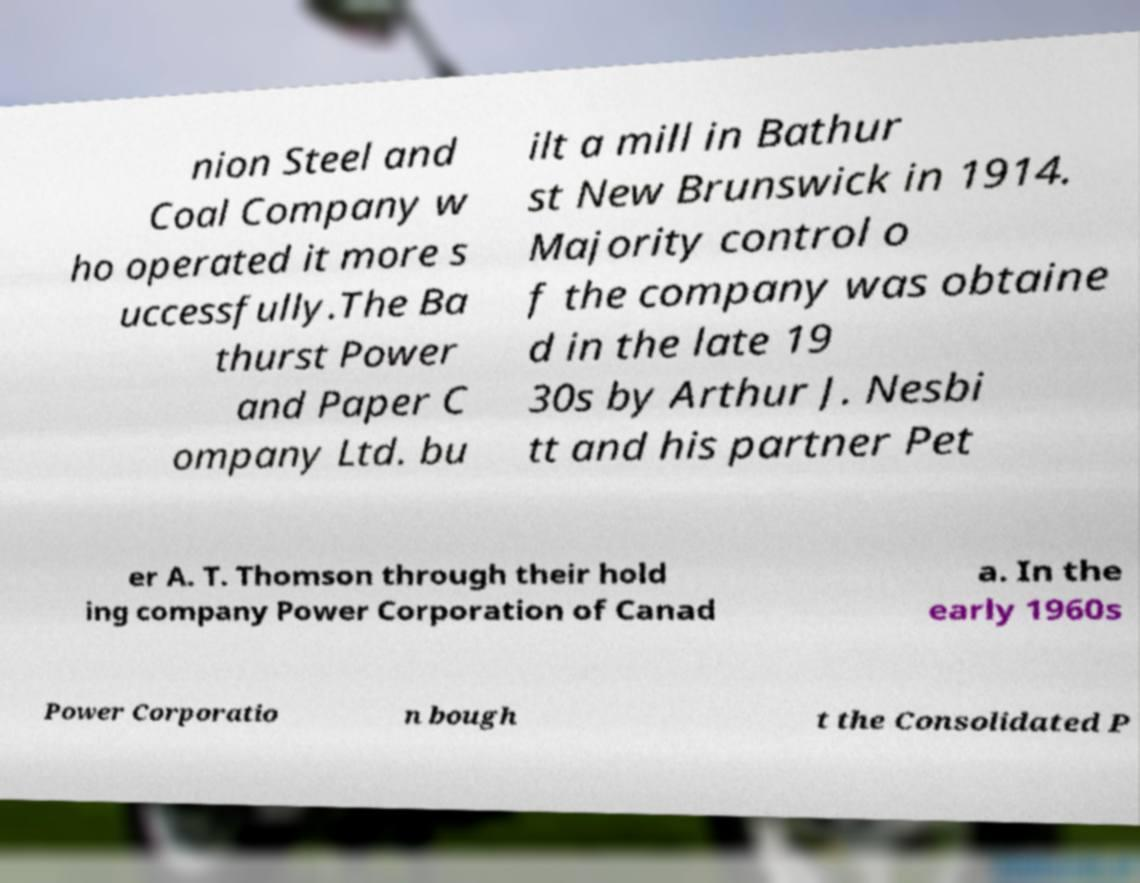Can you accurately transcribe the text from the provided image for me? nion Steel and Coal Company w ho operated it more s uccessfully.The Ba thurst Power and Paper C ompany Ltd. bu ilt a mill in Bathur st New Brunswick in 1914. Majority control o f the company was obtaine d in the late 19 30s by Arthur J. Nesbi tt and his partner Pet er A. T. Thomson through their hold ing company Power Corporation of Canad a. In the early 1960s Power Corporatio n bough t the Consolidated P 